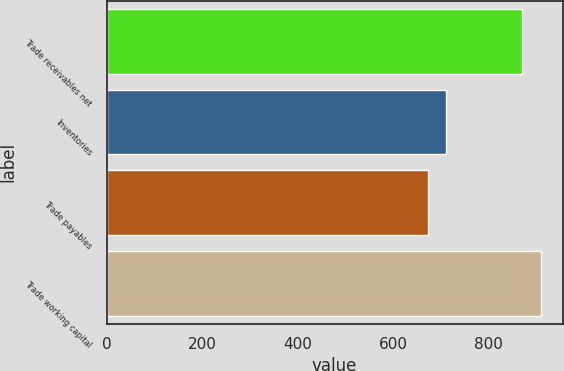Convert chart to OTSL. <chart><loc_0><loc_0><loc_500><loc_500><bar_chart><fcel>Trade receivables net<fcel>Inventories<fcel>Trade payables<fcel>Trade working capital<nl><fcel>871<fcel>712<fcel>673<fcel>910<nl></chart> 